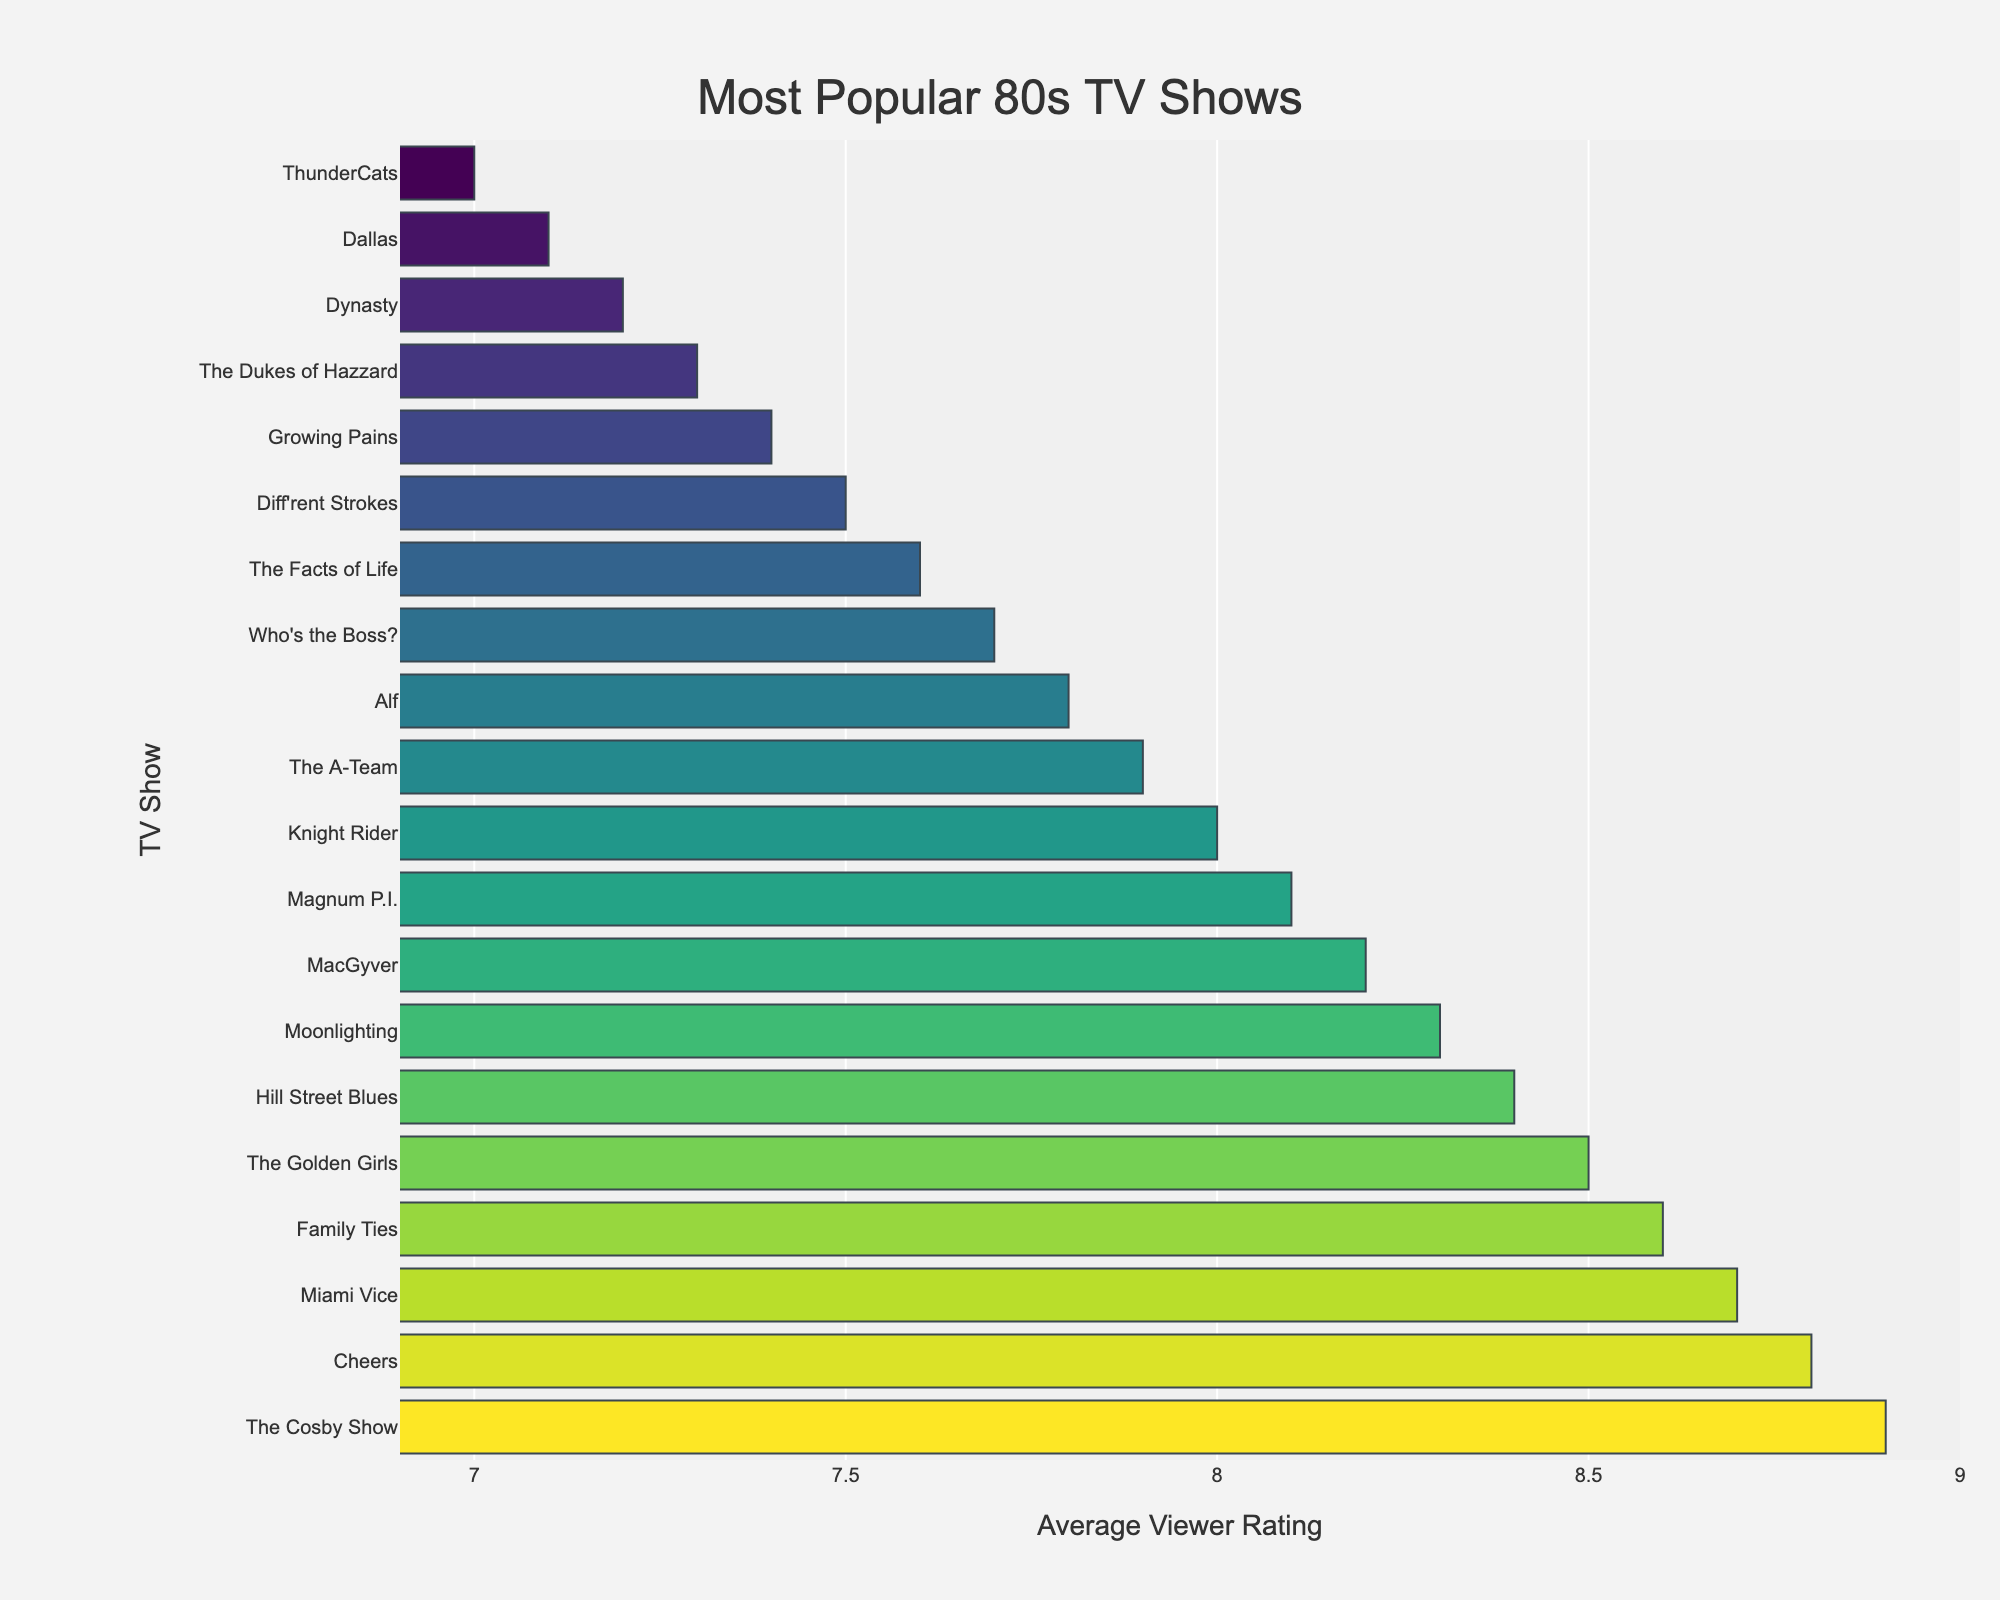What is the highest average viewer rating among 80s TV shows? The highest bar in the chart represents "The Cosby Show" with the longest length and the title clearly indicates it has the highest rating.
Answer: 8.9 Which TV show has a slightly lower rating than "Cheers"? "Cheers" has a rating of 8.8, and the next bar slightly lower than 8.8 shows "Miami Vice."
Answer: Miami Vice What is the combined average viewer rating of "Knight Rider" and "The A-Team"? The bar for "Knight Rider" shows a rating of 8.0, and "The A-Team" shows 7.9. Summing these gives 8.0 + 7.9 = 15.9.
Answer: 15.9 Is "Moonlighting" rated higher than "MacGyver"? The bar for "Moonlighting" is longer than the bar for "MacGyver," indicating it has a higher rating.
Answer: Yes Which show has a rating exactly 1 point less than "The Cosby Show"? "The Cosby Show" has a rating of 8.9, so a rating 1 point less is 7.9, which belongs to "The A-Team."
Answer: The A-Team What is the median average viewer rating of these TV shows? To find the median rating, list all ratings in order: 7.0, 7.1, 7.2, 7.3, 7.4, 7.5, 7.6, 7.7, 7.8, 7.9, 8.0, 8.1, 8.2, 8.3, 8.4, 8.5, 8.6, 8.7, 8.8, 8.9. The middle values are 7.9 and 8.0, and the median is the average of these, (7.9 + 8.0)/2 = 7.95.
Answer: 7.95 Which TV shows have ratings higher than 8.5? The bars representing ratings higher than 8.5 belong to "The Cosby Show," "Cheers," "Miami Vice," and "Family Ties."
Answer: The Cosby Show, Cheers, Miami Vice, Family Ties Is "Dallas" rated higher or lower than "Dynasty"? The bar for "Dallas" is shorter than "Dynasty," indicating a lower rating of 7.1 compared to 7.2 for "Dynasty."
Answer: Lower 